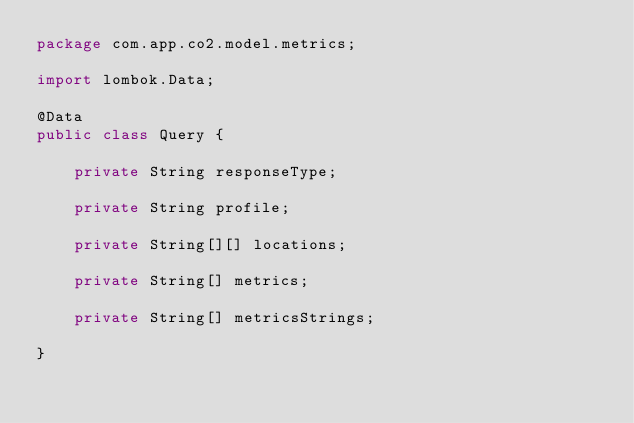Convert code to text. <code><loc_0><loc_0><loc_500><loc_500><_Java_>package com.app.co2.model.metrics;

import lombok.Data;

@Data
public class Query {

    private String responseType;

    private String profile;

    private String[][] locations;

    private String[] metrics;

    private String[] metricsStrings;

}
</code> 